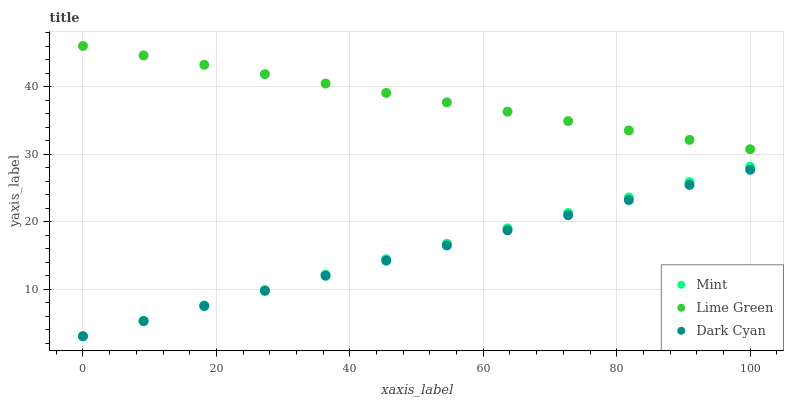Does Dark Cyan have the minimum area under the curve?
Answer yes or no. Yes. Does Lime Green have the maximum area under the curve?
Answer yes or no. Yes. Does Mint have the minimum area under the curve?
Answer yes or no. No. Does Mint have the maximum area under the curve?
Answer yes or no. No. Is Dark Cyan the smoothest?
Answer yes or no. Yes. Is Lime Green the roughest?
Answer yes or no. Yes. Is Mint the smoothest?
Answer yes or no. No. Is Mint the roughest?
Answer yes or no. No. Does Dark Cyan have the lowest value?
Answer yes or no. Yes. Does Lime Green have the lowest value?
Answer yes or no. No. Does Lime Green have the highest value?
Answer yes or no. Yes. Does Mint have the highest value?
Answer yes or no. No. Is Dark Cyan less than Lime Green?
Answer yes or no. Yes. Is Lime Green greater than Mint?
Answer yes or no. Yes. Does Mint intersect Dark Cyan?
Answer yes or no. Yes. Is Mint less than Dark Cyan?
Answer yes or no. No. Is Mint greater than Dark Cyan?
Answer yes or no. No. Does Dark Cyan intersect Lime Green?
Answer yes or no. No. 